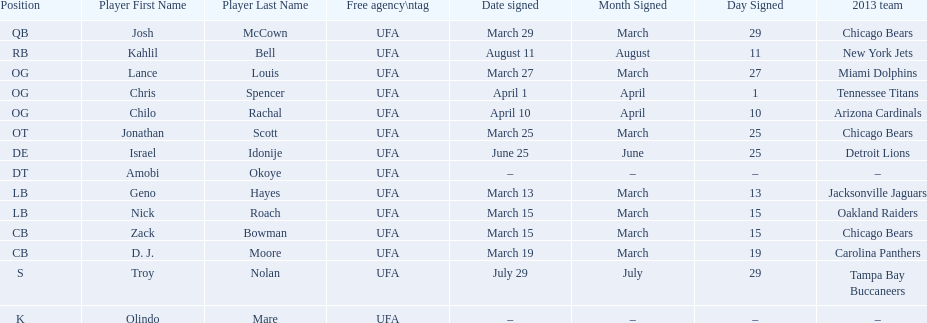Could you parse the entire table as a dict? {'header': ['Position', 'Player First Name', 'Player Last Name', 'Free agency\\ntag', 'Date signed', 'Month Signed', 'Day Signed', '2013 team'], 'rows': [['QB', 'Josh', 'McCown', 'UFA', 'March 29', 'March', '29', 'Chicago Bears'], ['RB', 'Kahlil', 'Bell', 'UFA', 'August 11', 'August', '11', 'New York Jets'], ['OG', 'Lance', 'Louis', 'UFA', 'March 27', 'March', '27', 'Miami Dolphins'], ['OG', 'Chris', 'Spencer', 'UFA', 'April 1', 'April', '1', 'Tennessee Titans'], ['OG', 'Chilo', 'Rachal', 'UFA', 'April 10', 'April', '10', 'Arizona Cardinals'], ['OT', 'Jonathan', 'Scott', 'UFA', 'March 25', 'March', '25', 'Chicago Bears'], ['DE', 'Israel', 'Idonije', 'UFA', 'June 25', 'June', '25', 'Detroit Lions'], ['DT', 'Amobi', 'Okoye', 'UFA', '–', '–', '–', '–'], ['LB', 'Geno', 'Hayes', 'UFA', 'March 13', 'March', '13', 'Jacksonville Jaguars'], ['LB', 'Nick', 'Roach', 'UFA', 'March 15', 'March', '15', 'Oakland Raiders'], ['CB', 'Zack', 'Bowman', 'UFA', 'March 15', 'March', '15', 'Chicago Bears'], ['CB', 'D. J.', 'Moore', 'UFA', 'March 19', 'March', '19', 'Carolina Panthers'], ['S', 'Troy', 'Nolan', 'UFA', 'July 29', 'July', '29', 'Tampa Bay Buccaneers'], ['K', 'Olindo', 'Mare', 'UFA', '–', '–', '–', '–']]} How many players play cb or og? 5. 